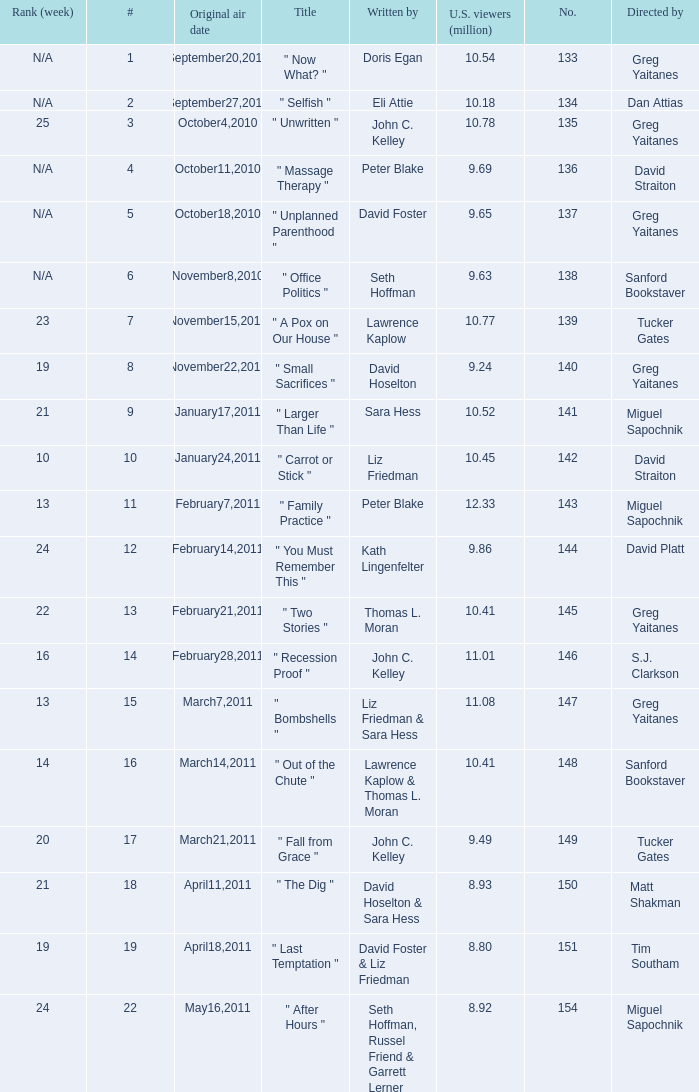Where did the episode rank that was written by thomas l. moran? 22.0. 